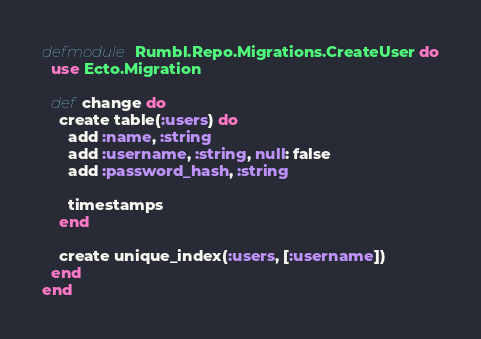<code> <loc_0><loc_0><loc_500><loc_500><_Elixir_>defmodule Rumbl.Repo.Migrations.CreateUser do
  use Ecto.Migration

  def change do
    create table(:users) do
      add :name, :string
      add :username, :string, null: false
      add :password_hash, :string
      
      timestamps 
    end
    
    create unique_index(:users, [:username])
  end
end
</code> 